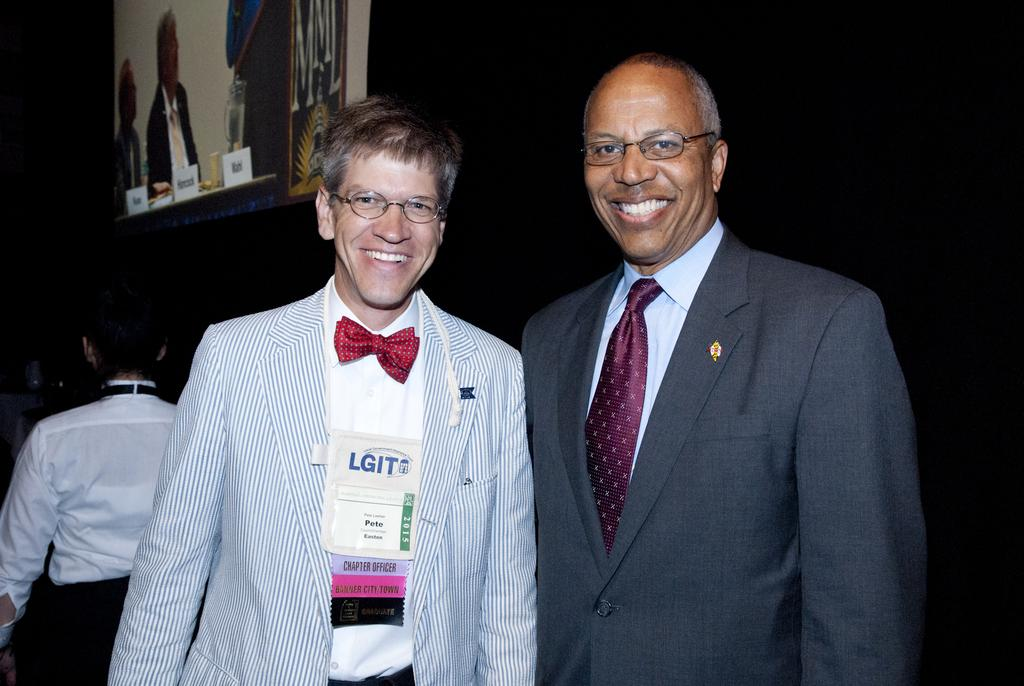What are the people in the image doing? The people in the image are standing and smiling. Can you describe any accessories or items worn by the people? Some of the people are wearing glasses, and one person is wearing a badge. What can be seen in the background of the image? There is a screen in the background of the image, and part of the background is dark. What type of kitten is being taught by the coach in the image? There is no kitten or coach present in the image. What subject is the teacher teaching to the students in the image? There is no teaching or students present in the image; it features people standing and smiling. 